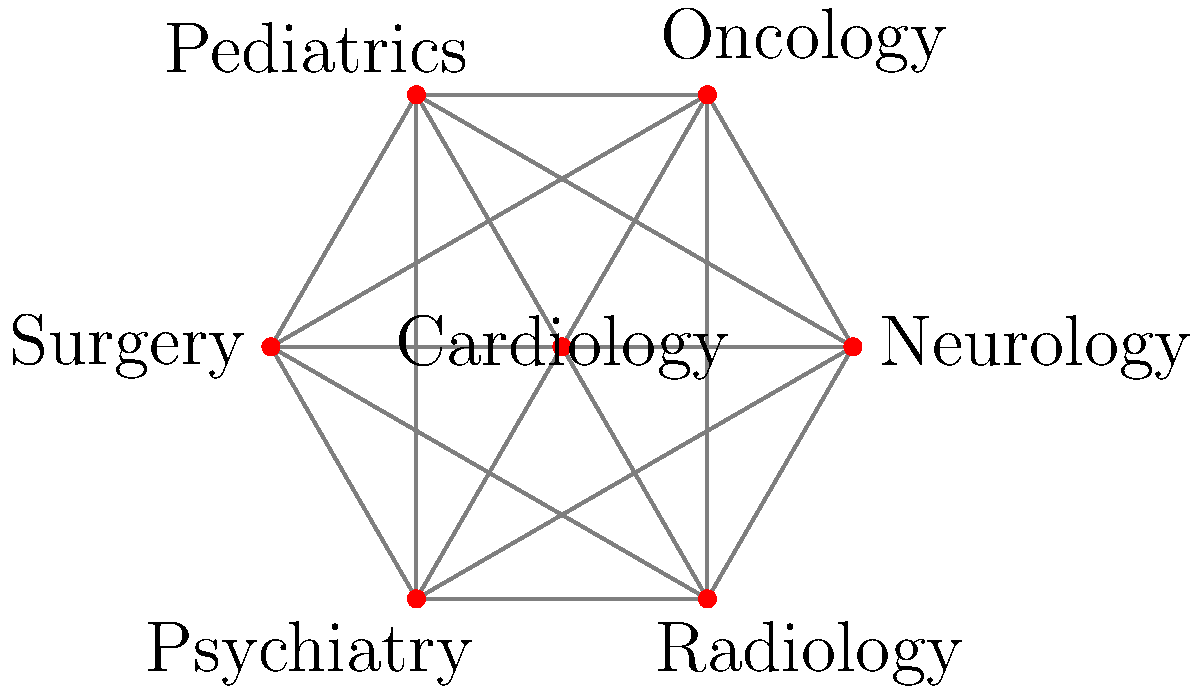In the given medical specialty network, which specialty has the highest degree centrality (i.e., the most direct connections to other specialties)? To determine the specialty with the highest degree centrality, we need to count the number of direct connections for each specialty:

1. Cardiology: Connected to all 6 other specialties
2. Neurology: Connected to all 6 other specialties
3. Oncology: Connected to all 6 other specialties
4. Pediatrics: Connected to all 6 other specialties
5. Surgery: Connected to all 6 other specialties
6. Psychiatry: Connected to all 6 other specialties
7. Radiology: Connected to all 6 other specialties

In this network, all specialties have the same number of connections (6), which means they all have the same degree centrality. This illustrates the interconnected nature of medical specialties in a healthcare system, where each specialty potentially interacts with all others for comprehensive patient care.

However, in real-world healthcare systems, some specialties might have more frequent or stronger connections than others. For example, Radiology often interacts with many other specialties due to its diagnostic role, while Surgery might have particularly strong connections with specialties that often require surgical interventions.

In this idealized network, there isn't a single specialty with the highest degree centrality, as they all have equal connectivity.
Answer: All specialties have equal degree centrality 